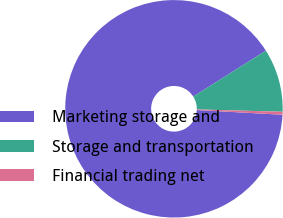Convert chart to OTSL. <chart><loc_0><loc_0><loc_500><loc_500><pie_chart><fcel>Marketing storage and<fcel>Storage and transportation<fcel>Financial trading net<nl><fcel>90.15%<fcel>9.41%<fcel>0.44%<nl></chart> 